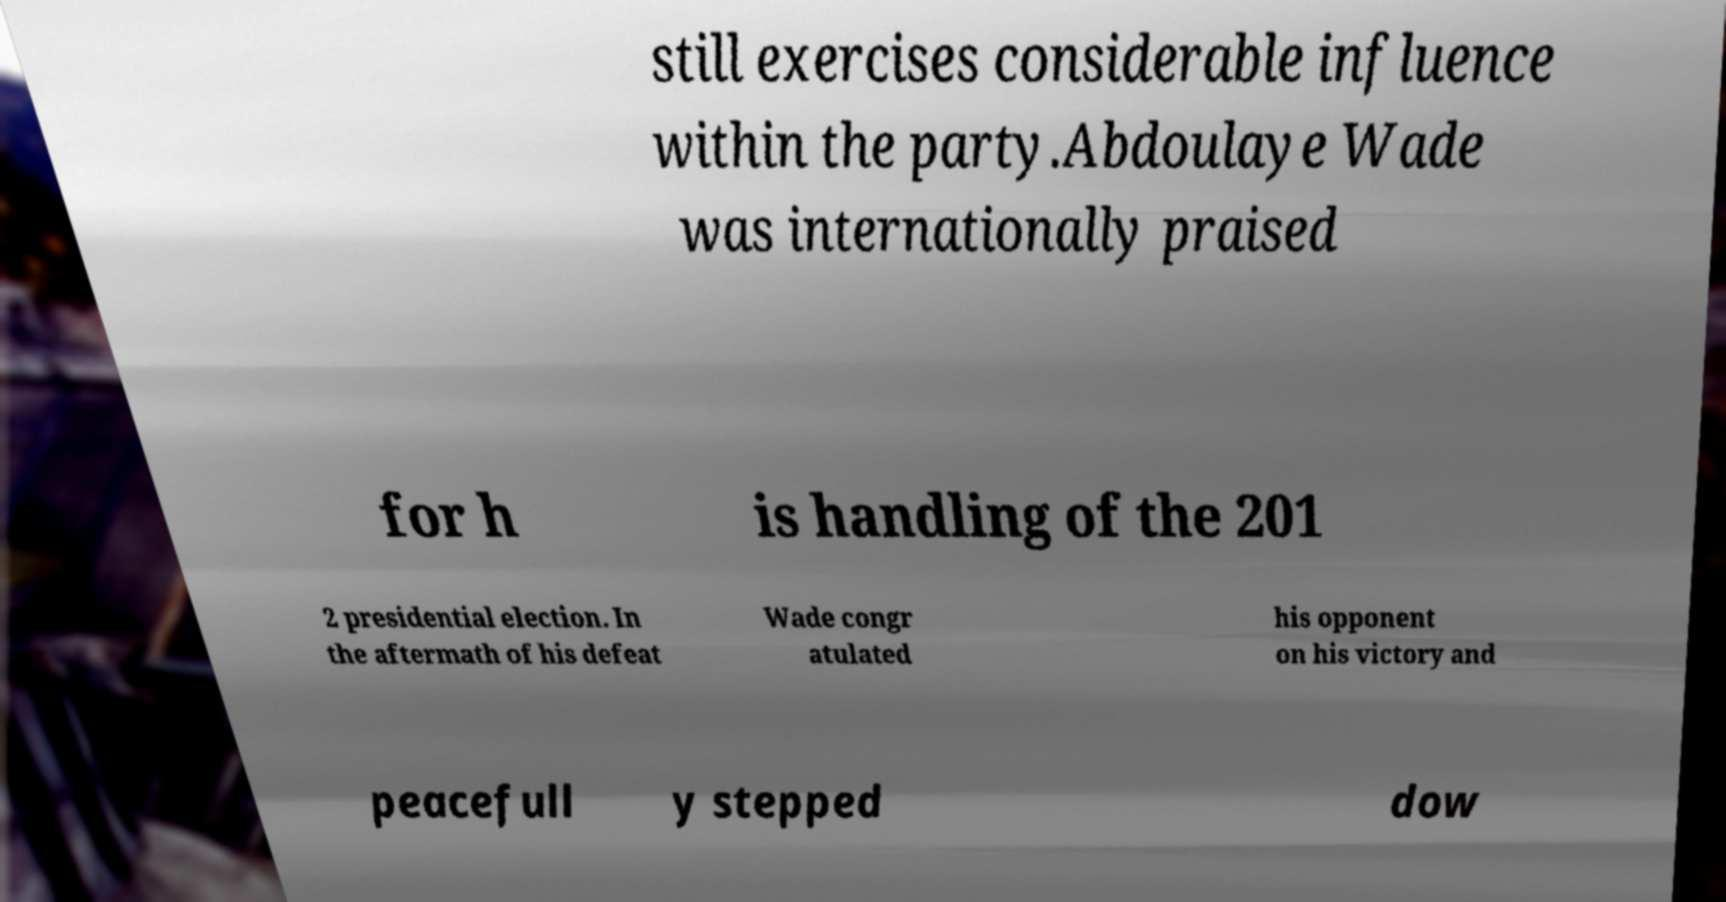Can you read and provide the text displayed in the image?This photo seems to have some interesting text. Can you extract and type it out for me? still exercises considerable influence within the party.Abdoulaye Wade was internationally praised for h is handling of the 201 2 presidential election. In the aftermath of his defeat Wade congr atulated his opponent on his victory and peacefull y stepped dow 